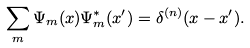<formula> <loc_0><loc_0><loc_500><loc_500>\sum _ { m } \Psi _ { m } ( x ) \Psi _ { m } ^ { * } ( x ^ { \prime } ) = \delta ^ { ( n ) } ( x - x ^ { \prime } ) .</formula> 